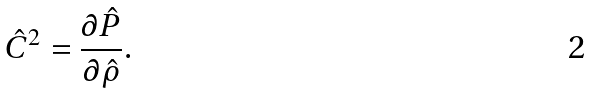Convert formula to latex. <formula><loc_0><loc_0><loc_500><loc_500>\hat { C } ^ { 2 } & = \frac { \partial \hat { P } } { \partial \hat { \rho } } .</formula> 